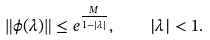Convert formula to latex. <formula><loc_0><loc_0><loc_500><loc_500>\| \phi ( \lambda ) \| \leq e ^ { \frac { M } { 1 - | \lambda | } } , \quad | \lambda | < 1 .</formula> 